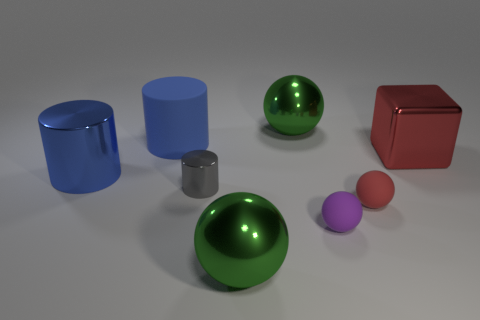Subtract 1 spheres. How many spheres are left? 3 Add 1 tiny rubber things. How many objects exist? 9 Subtract all cylinders. How many objects are left? 5 Subtract 0 brown spheres. How many objects are left? 8 Subtract all small blue shiny blocks. Subtract all tiny metal cylinders. How many objects are left? 7 Add 8 blue cylinders. How many blue cylinders are left? 10 Add 7 large yellow shiny blocks. How many large yellow shiny blocks exist? 7 